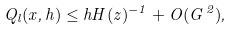Convert formula to latex. <formula><loc_0><loc_0><loc_500><loc_500>Q _ { l } ( x , h ) \leq h H ( z ) ^ { - 1 } + O ( G ^ { \, 2 } ) ,</formula> 